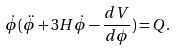Convert formula to latex. <formula><loc_0><loc_0><loc_500><loc_500>\dot { \phi } ( \ddot { \phi } + 3 H \dot { \phi } - \frac { d V } { d \phi } ) = Q .</formula> 